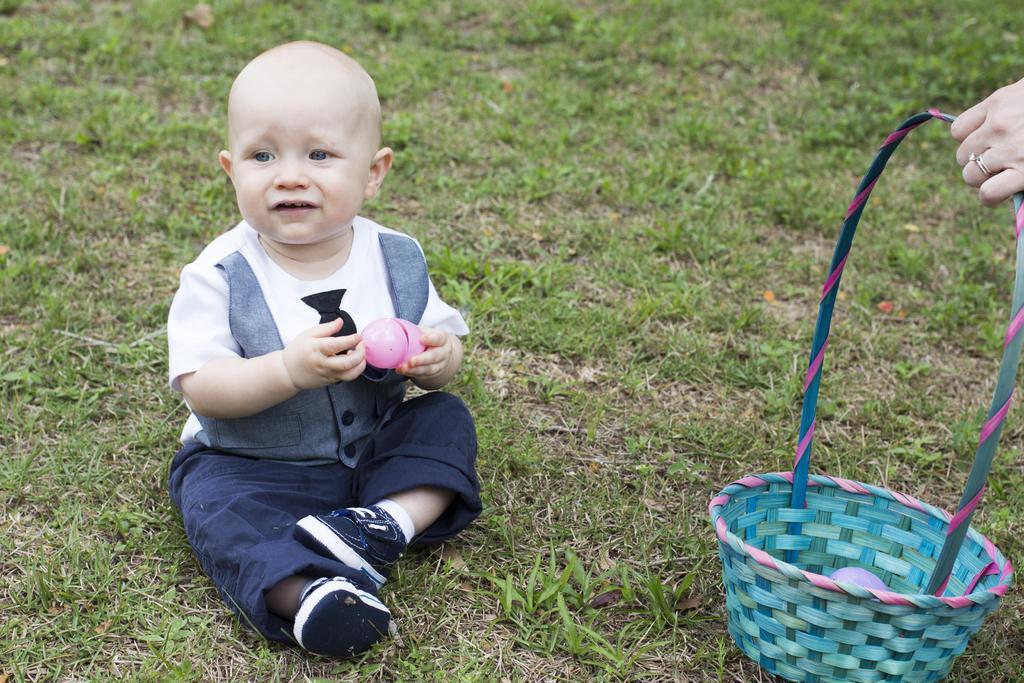Please provide a concise description of this image. In the image in the center, we can see one baby sitting and holding some object. On the right side of the image, we can see one human hand holding basket. In the background we can see the grass. 